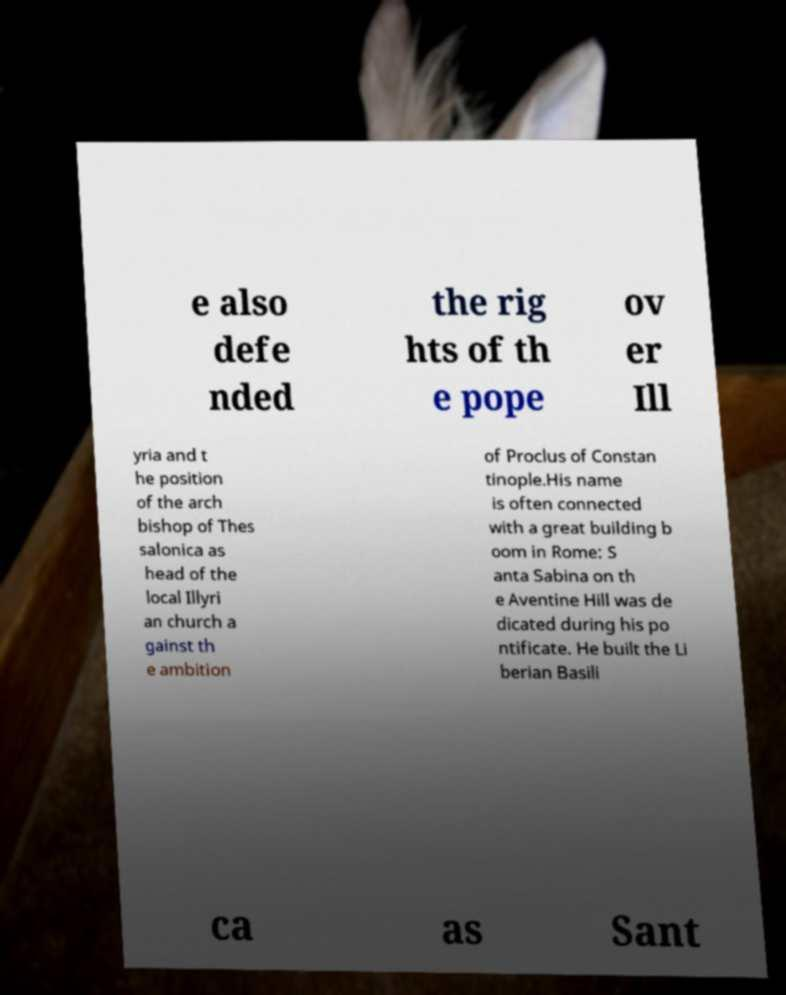Can you accurately transcribe the text from the provided image for me? e also defe nded the rig hts of th e pope ov er Ill yria and t he position of the arch bishop of Thes salonica as head of the local Illyri an church a gainst th e ambition of Proclus of Constan tinople.His name is often connected with a great building b oom in Rome: S anta Sabina on th e Aventine Hill was de dicated during his po ntificate. He built the Li berian Basili ca as Sant 